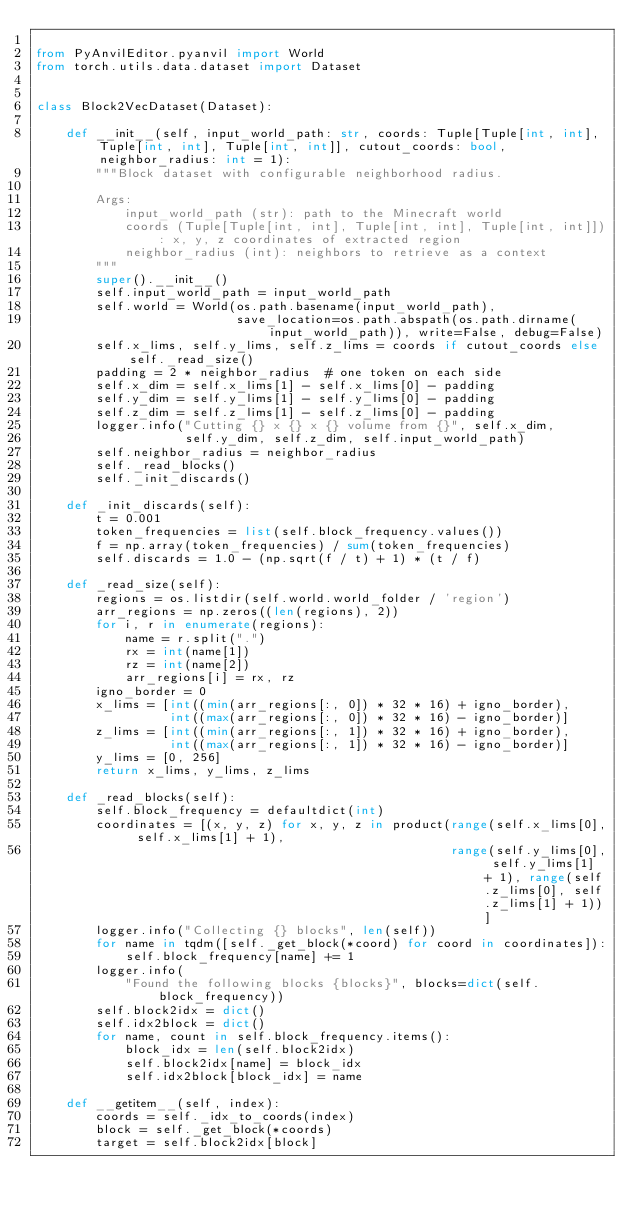Convert code to text. <code><loc_0><loc_0><loc_500><loc_500><_Python_>
from PyAnvilEditor.pyanvil import World
from torch.utils.data.dataset import Dataset


class Block2VecDataset(Dataset):

    def __init__(self, input_world_path: str, coords: Tuple[Tuple[int, int], Tuple[int, int], Tuple[int, int]], cutout_coords: bool,  neighbor_radius: int = 1):
        """Block dataset with configurable neighborhood radius.

        Args:
            input_world_path (str): path to the Minecraft world
            coords (Tuple[Tuple[int, int], Tuple[int, int], Tuple[int, int]]): x, y, z coordinates of extracted region
            neighbor_radius (int): neighbors to retrieve as a context
        """
        super().__init__()
        self.input_world_path = input_world_path
        self.world = World(os.path.basename(input_world_path),
                           save_location=os.path.abspath(os.path.dirname(input_world_path)), write=False, debug=False)
        self.x_lims, self.y_lims, self.z_lims = coords if cutout_coords else self._read_size()
        padding = 2 * neighbor_radius  # one token on each side
        self.x_dim = self.x_lims[1] - self.x_lims[0] - padding
        self.y_dim = self.y_lims[1] - self.y_lims[0] - padding
        self.z_dim = self.z_lims[1] - self.z_lims[0] - padding
        logger.info("Cutting {} x {} x {} volume from {}", self.x_dim,
                    self.y_dim, self.z_dim, self.input_world_path)
        self.neighbor_radius = neighbor_radius
        self._read_blocks()
        self._init_discards()

    def _init_discards(self):
        t = 0.001
        token_frequencies = list(self.block_frequency.values())
        f = np.array(token_frequencies) / sum(token_frequencies)
        self.discards = 1.0 - (np.sqrt(f / t) + 1) * (t / f)

    def _read_size(self):
        regions = os.listdir(self.world.world_folder / 'region')
        arr_regions = np.zeros((len(regions), 2))
        for i, r in enumerate(regions):
            name = r.split(".")
            rx = int(name[1])
            rz = int(name[2])
            arr_regions[i] = rx, rz
        igno_border = 0
        x_lims = [int((min(arr_regions[:, 0]) * 32 * 16) + igno_border),
                  int((max(arr_regions[:, 0]) * 32 * 16) - igno_border)]
        z_lims = [int((min(arr_regions[:, 1]) * 32 * 16) + igno_border),
                  int((max(arr_regions[:, 1]) * 32 * 16) - igno_border)]
        y_lims = [0, 256]
        return x_lims, y_lims, z_lims

    def _read_blocks(self):
        self.block_frequency = defaultdict(int)
        coordinates = [(x, y, z) for x, y, z in product(range(self.x_lims[0], self.x_lims[1] + 1),
                                                        range(self.y_lims[0], self.y_lims[1] + 1), range(self.z_lims[0], self.z_lims[1] + 1))]
        logger.info("Collecting {} blocks", len(self))
        for name in tqdm([self._get_block(*coord) for coord in coordinates]):
            self.block_frequency[name] += 1
        logger.info(
            "Found the following blocks {blocks}", blocks=dict(self.block_frequency))
        self.block2idx = dict()
        self.idx2block = dict()
        for name, count in self.block_frequency.items():
            block_idx = len(self.block2idx)
            self.block2idx[name] = block_idx
            self.idx2block[block_idx] = name

    def __getitem__(self, index):
        coords = self._idx_to_coords(index)
        block = self._get_block(*coords)
        target = self.block2idx[block]</code> 